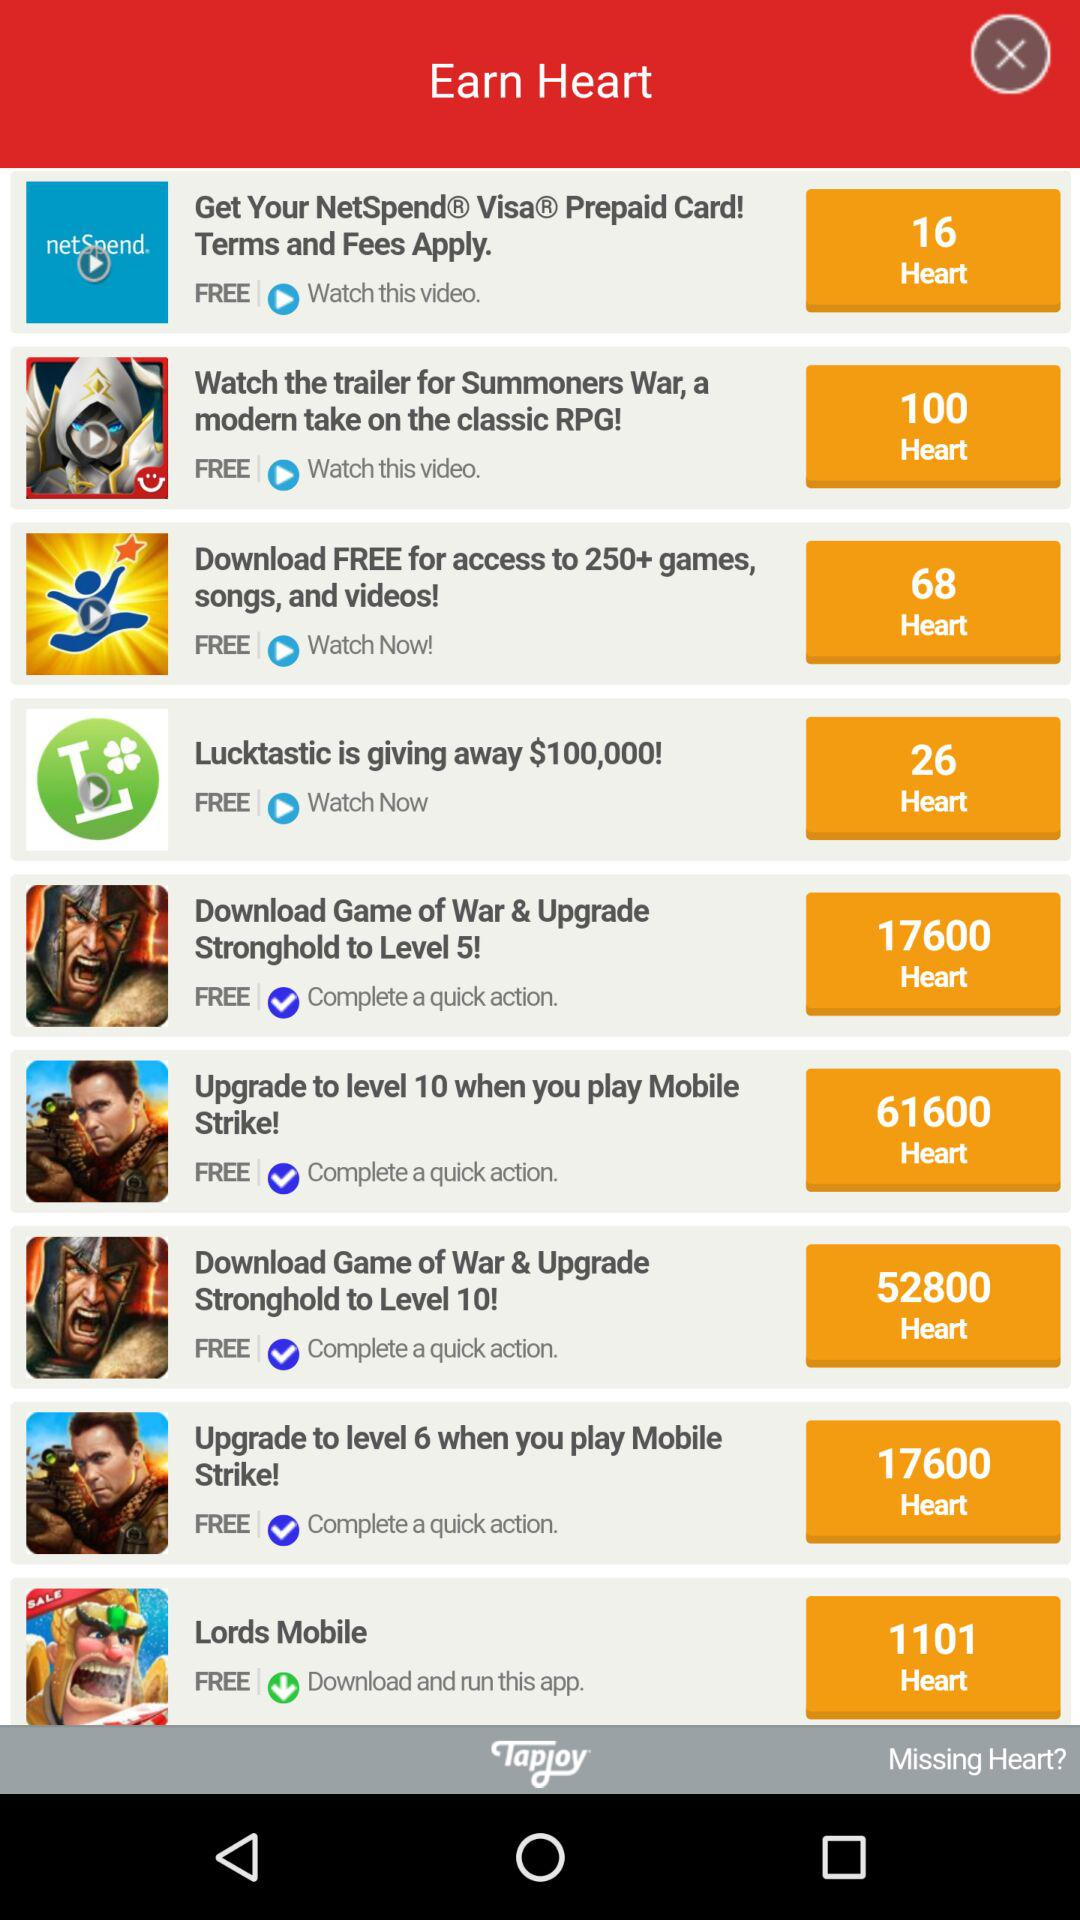What is the username?
When the provided information is insufficient, respond with <no answer>. <no answer> 